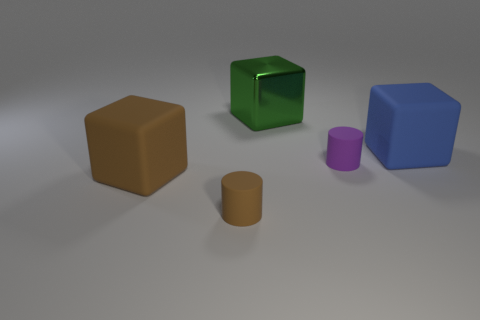Add 3 matte cylinders. How many objects exist? 8 Subtract all blocks. How many objects are left? 2 Subtract 0 cyan cubes. How many objects are left? 5 Subtract all blue things. Subtract all big brown cubes. How many objects are left? 3 Add 4 blue blocks. How many blue blocks are left? 5 Add 1 big blue rubber cylinders. How many big blue rubber cylinders exist? 1 